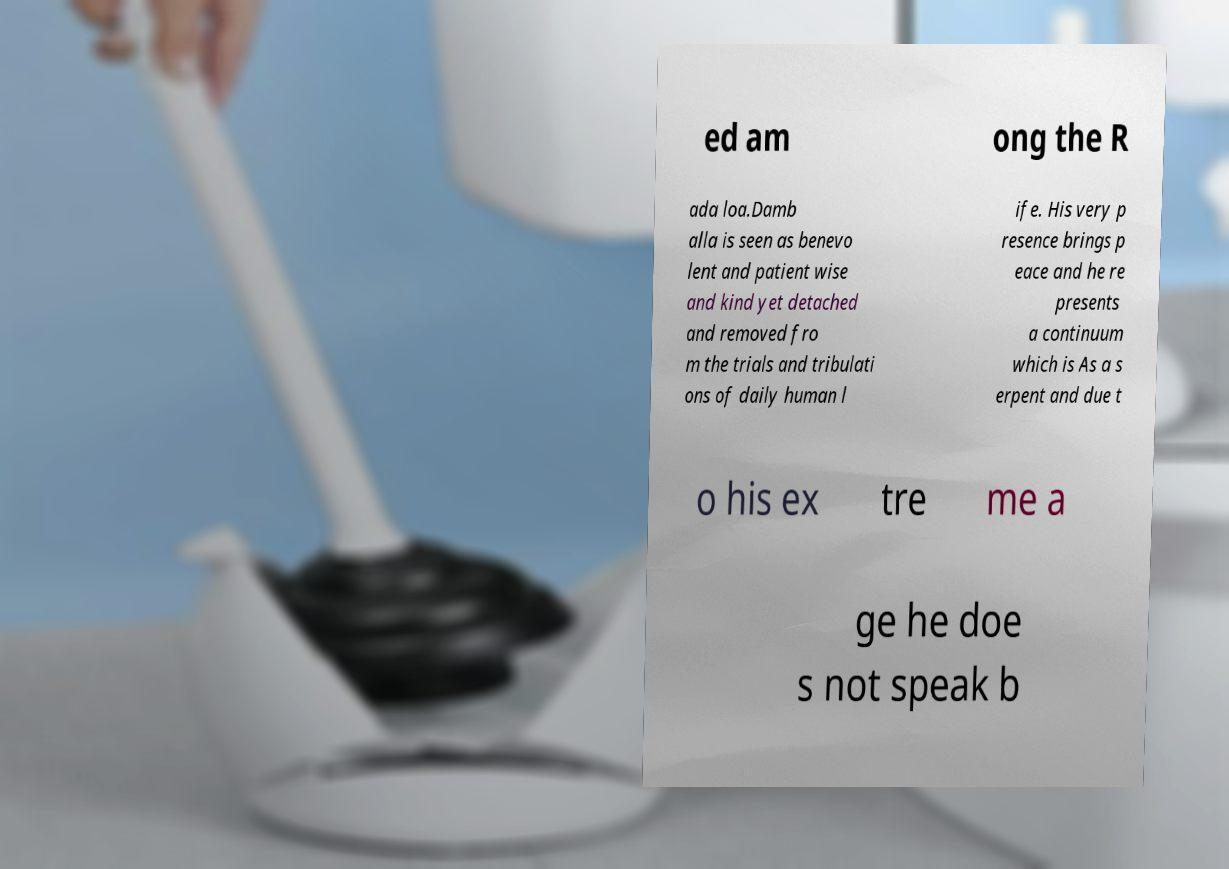There's text embedded in this image that I need extracted. Can you transcribe it verbatim? ed am ong the R ada loa.Damb alla is seen as benevo lent and patient wise and kind yet detached and removed fro m the trials and tribulati ons of daily human l ife. His very p resence brings p eace and he re presents a continuum which is As a s erpent and due t o his ex tre me a ge he doe s not speak b 